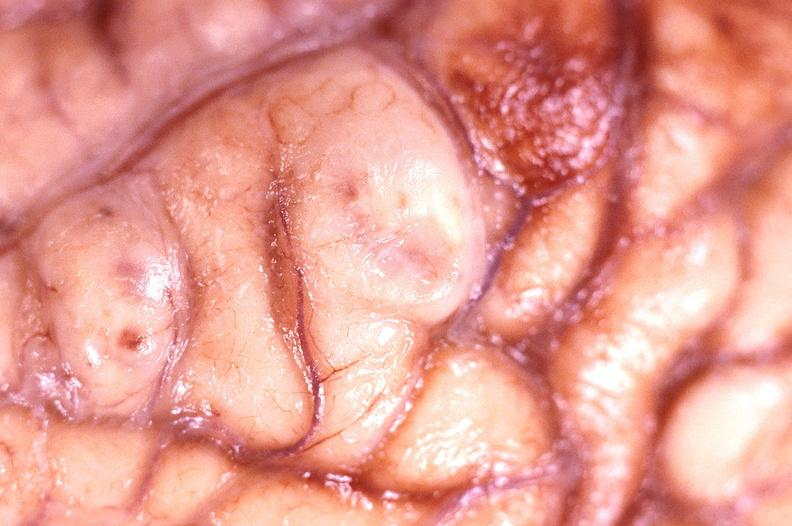s infarction secondary to shock present?
Answer the question using a single word or phrase. No 